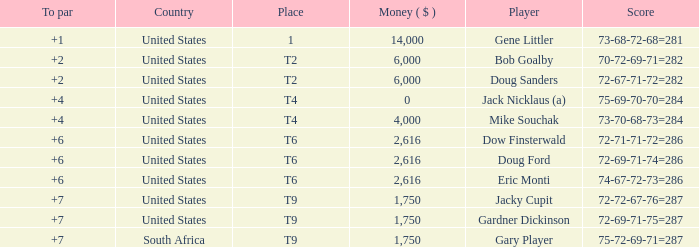What is the highest To Par, when Place is "1"? 1.0. 